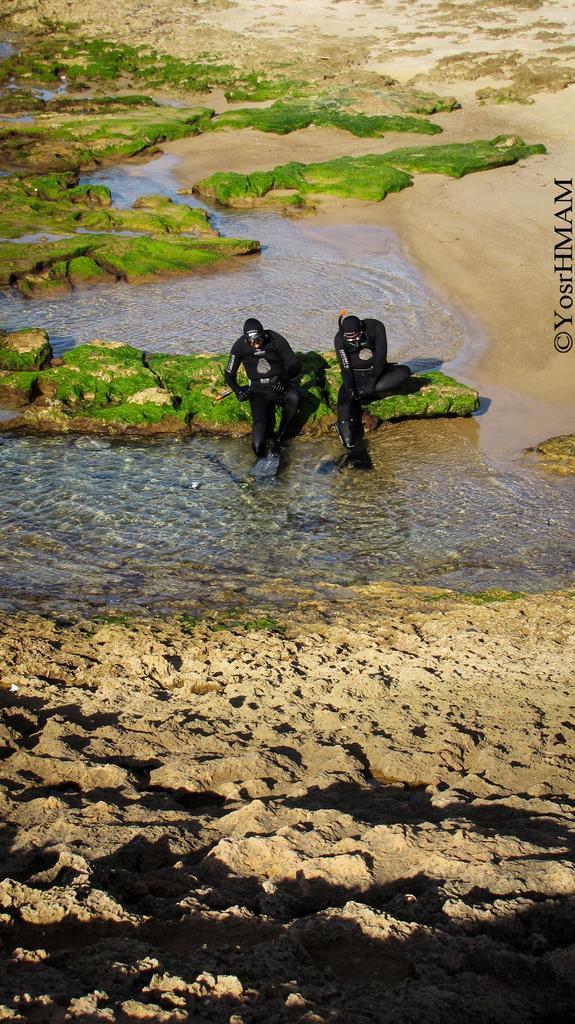How would you summarize this image in a sentence or two? In this picture there are two people sitting and we can see water, sand and algae. On the right side of the image we can see text. 